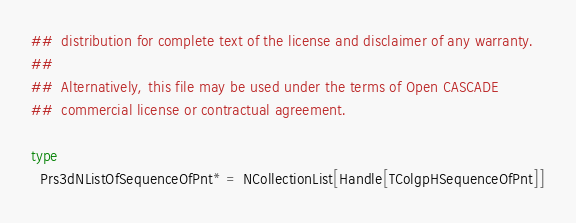Convert code to text. <code><loc_0><loc_0><loc_500><loc_500><_Nim_>##  distribution for complete text of the license and disclaimer of any warranty.
##
##  Alternatively, this file may be used under the terms of Open CASCADE
##  commercial license or contractual agreement.

type
  Prs3dNListOfSequenceOfPnt* = NCollectionList[Handle[TColgpHSequenceOfPnt]]
</code> 